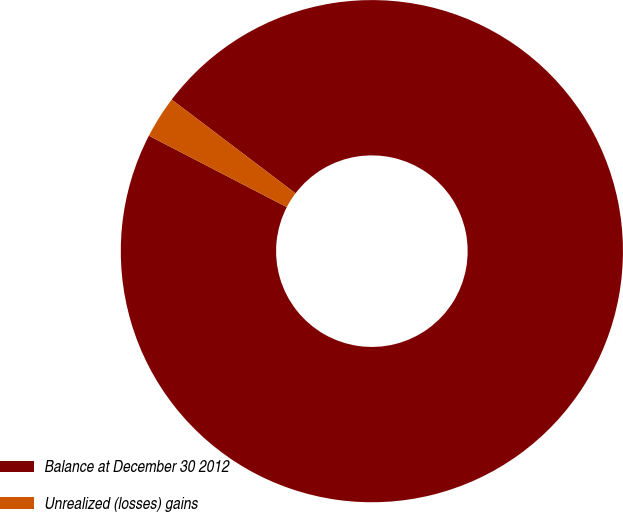Convert chart to OTSL. <chart><loc_0><loc_0><loc_500><loc_500><pie_chart><fcel>Balance at December 30 2012<fcel>Unrealized (losses) gains<nl><fcel>97.29%<fcel>2.71%<nl></chart> 